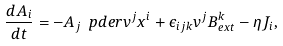<formula> <loc_0><loc_0><loc_500><loc_500>\frac { d A _ { i } } { d t } = - A _ { j } \ p d e r { v ^ { j } } { x ^ { i } } + \epsilon _ { i j k } v ^ { j } B _ { e x t } ^ { k } - \eta J _ { i } ,</formula> 